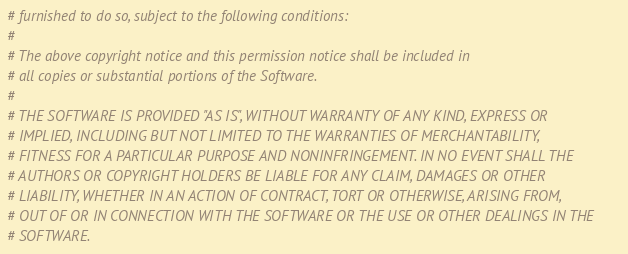<code> <loc_0><loc_0><loc_500><loc_500><_Python_># furnished to do so, subject to the following conditions:
#
# The above copyright notice and this permission notice shall be included in
# all copies or substantial portions of the Software.
#
# THE SOFTWARE IS PROVIDED "AS IS", WITHOUT WARRANTY OF ANY KIND, EXPRESS OR
# IMPLIED, INCLUDING BUT NOT LIMITED TO THE WARRANTIES OF MERCHANTABILITY,
# FITNESS FOR A PARTICULAR PURPOSE AND NONINFRINGEMENT. IN NO EVENT SHALL THE
# AUTHORS OR COPYRIGHT HOLDERS BE LIABLE FOR ANY CLAIM, DAMAGES OR OTHER
# LIABILITY, WHETHER IN AN ACTION OF CONTRACT, TORT OR OTHERWISE, ARISING FROM,
# OUT OF OR IN CONNECTION WITH THE SOFTWARE OR THE USE OR OTHER DEALINGS IN THE
# SOFTWARE.
</code> 